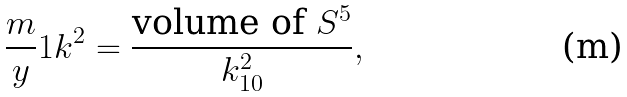<formula> <loc_0><loc_0><loc_500><loc_500>\frac { m } { y } { 1 } { k ^ { 2 } } = \frac { \text {volume of } S ^ { 5 } } { k ^ { 2 } _ { 1 0 } } ,</formula> 